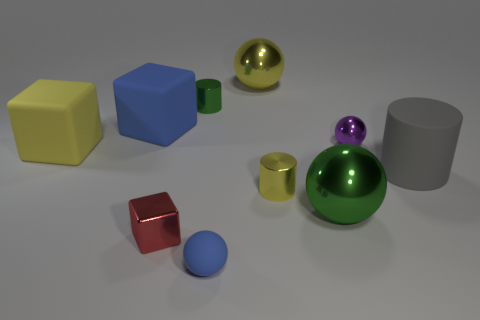There is a purple object that is made of the same material as the red cube; what size is it?
Give a very brief answer. Small. There is a tiny ball that is in front of the green metallic object that is right of the tiny matte object; are there any large cylinders that are in front of it?
Your response must be concise. No. Is the size of the green thing behind the gray matte object the same as the tiny blue matte ball?
Offer a terse response. Yes. How many yellow rubber objects are the same size as the purple thing?
Give a very brief answer. 0. The rubber thing that is the same color as the matte ball is what size?
Keep it short and to the point. Large. Is the tiny matte ball the same color as the small metallic cube?
Your answer should be very brief. No. The tiny red object is what shape?
Make the answer very short. Cube. Is there another tiny metallic sphere of the same color as the tiny metal sphere?
Your answer should be very brief. No. Is the number of blue matte objects on the right side of the large gray cylinder greater than the number of yellow shiny balls?
Provide a short and direct response. No. There is a tiny blue rubber object; is it the same shape as the large metal thing that is behind the small yellow metallic cylinder?
Keep it short and to the point. Yes. 